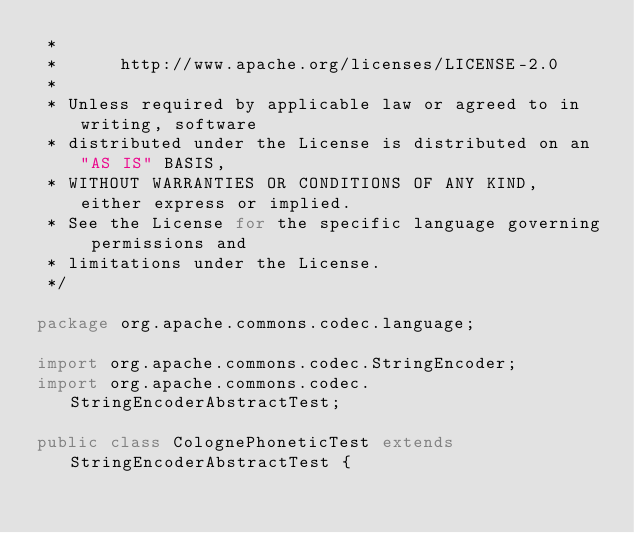<code> <loc_0><loc_0><loc_500><loc_500><_Java_> * 
 *      http://www.apache.org/licenses/LICENSE-2.0
 * 
 * Unless required by applicable law or agreed to in writing, software
 * distributed under the License is distributed on an "AS IS" BASIS,
 * WITHOUT WARRANTIES OR CONDITIONS OF ANY KIND, either express or implied.
 * See the License for the specific language governing permissions and
 * limitations under the License.
 */

package org.apache.commons.codec.language;

import org.apache.commons.codec.StringEncoder;
import org.apache.commons.codec.StringEncoderAbstractTest;

public class ColognePhoneticTest extends StringEncoderAbstractTest {
</code> 